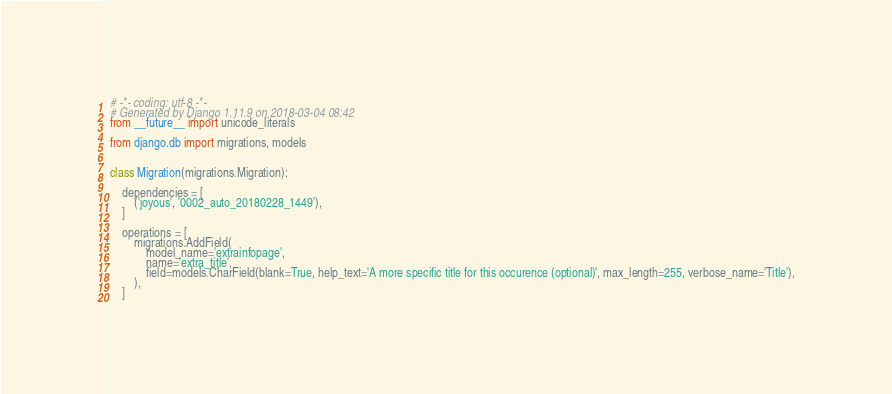Convert code to text. <code><loc_0><loc_0><loc_500><loc_500><_Python_># -*- coding: utf-8 -*-
# Generated by Django 1.11.9 on 2018-03-04 08:42
from __future__ import unicode_literals

from django.db import migrations, models


class Migration(migrations.Migration):

    dependencies = [
        ('joyous', '0002_auto_20180228_1449'),
    ]

    operations = [
        migrations.AddField(
            model_name='extrainfopage',
            name='extra_title',
            field=models.CharField(blank=True, help_text='A more specific title for this occurence (optional)', max_length=255, verbose_name='Title'),
        ),
    ]
</code> 